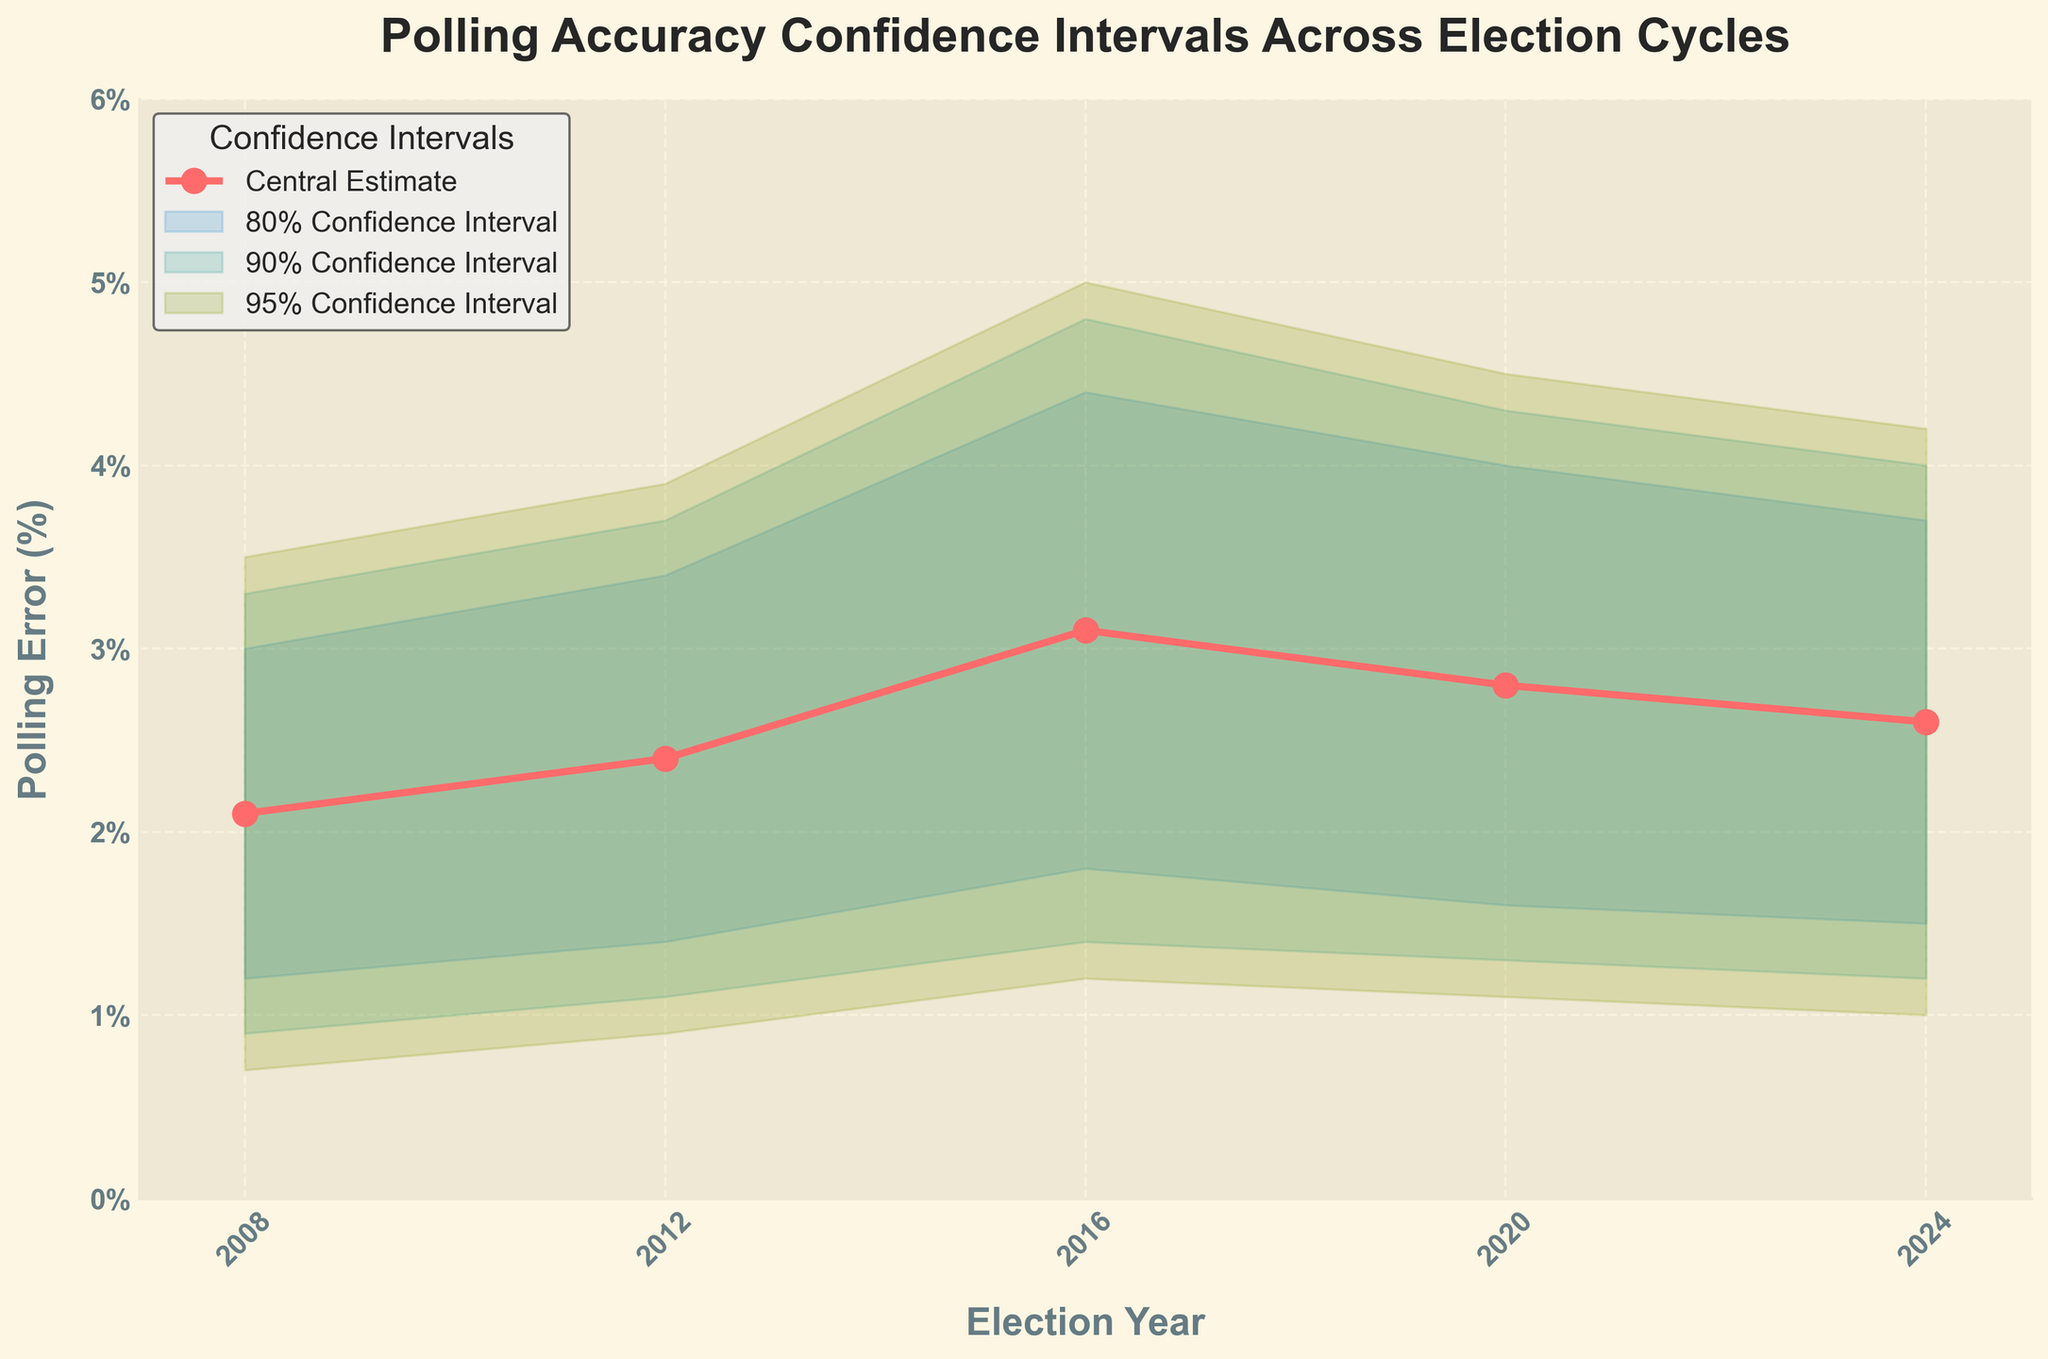What is the title of the figure? The title of the figure is located at the top and it usually provides a summary of the plot. In this case, the title is "Polling Accuracy Confidence Intervals Across Election Cycles."
Answer: Polling Accuracy Confidence Intervals Across Election Cycles What are the election years displayed on the x-axis? The election years can be observed on the x-axis as labeled tick marks. The years indicated are 2008, 2012, 2016, 2020, and 2024.
Answer: 2008, 2012, 2016, 2020, 2024 What is the central estimate for polling error in 2016? The central estimate for polling error in 2016 is marked by the central plot and point for that year. It is indicated as 3.1.
Answer: 3.1 Which election year had the highest central estimate of polling error? Observing the central estimates plotted for each year, 2016 has the highest value at 3.1.
Answer: 2016 What is the range of the 95% confidence interval for the year 2020? The 95% confidence interval for the year 2020 is between the lower bound labeled “95% Lower” and the upper bound labeled “95% Upper”. For 2020, this range is 1.1 to 4.5.
Answer: 1.1 to 4.5 Which confidence interval range (80%, 90%, or 95%) is the widest in the year 2012? To determine the widest range, calculate the difference between the upper and lower bounds for 80%, 90%, and 95% intervals. In 2012, 80% CI is 1.4 to 3.4 (range = 2.0), 90% CI is 1.1 to 3.7 (range = 2.6), and 95% CI is 0.9 to 3.9 (range = 3.0). Thus, the 95% interval is the widest.
Answer: 95% How does the central estimate for the year 2024 compare to that of the year 2020? The central estimates for the years 2024 and 2020 can be directly compared by looking at their respective values. The central estimate for 2024 is 2.6 and for 2020 it is 2.8, indicating the estimate in 2024 is slightly lower.
Answer: Lower In which year is the polling error least uncertain, based on the width of the 95% confidence interval? Least uncertainty is indicated by the narrowest 95% confidence interval. Calculate the widths for each year: 2008 (2.8), 2012 (3.0), 2016 (3.8), 2020 (3.4), 2024 (3.2). The narrowest is 2008 with a range of 2.8.
Answer: 2008 Which election year shows polling accuracy with the narrowest range for the 80% confidence interval? Calculate the range (upper bound minus lower bound) for the 80% confidence interval in each year. 2008: 1.8, 2012: 2.0, 2016: 2.6, 2020: 2.4, 2024: 2.2. The year 2008 has the narrowest range at 1.8.
Answer: 2008 